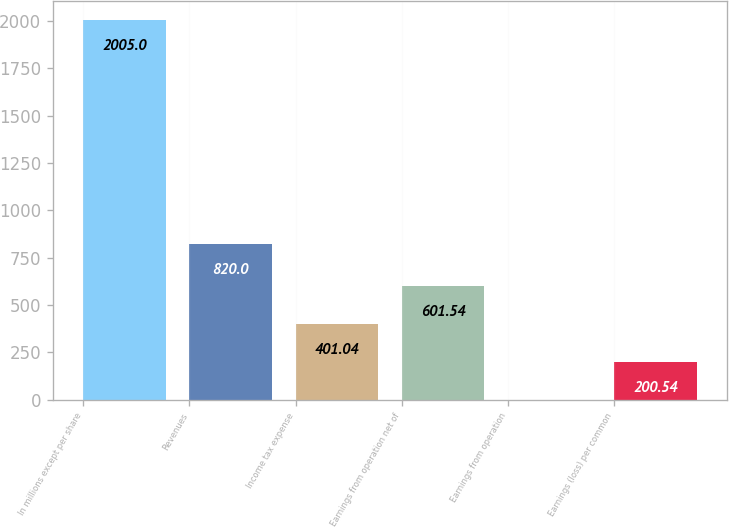Convert chart. <chart><loc_0><loc_0><loc_500><loc_500><bar_chart><fcel>In millions except per share<fcel>Revenues<fcel>Income tax expense<fcel>Earnings from operation net of<fcel>Earnings from operation<fcel>Earnings (loss) per common<nl><fcel>2005<fcel>820<fcel>401.04<fcel>601.54<fcel>0.04<fcel>200.54<nl></chart> 